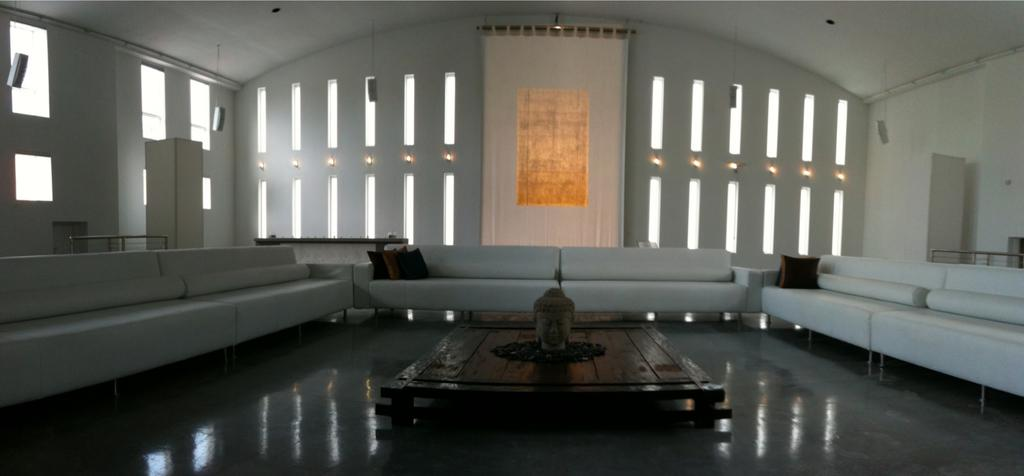What is the main object in the center of the room? There is a sculpture in the center of the room. What type of seating is arranged around the sculpture? White sofas are present around the sculpture. What can be seen at the back of the room? There is a white curtain at the back of the room. What type of dust can be seen on the sculpture in the image? There is no dust visible on the sculpture in the image. 